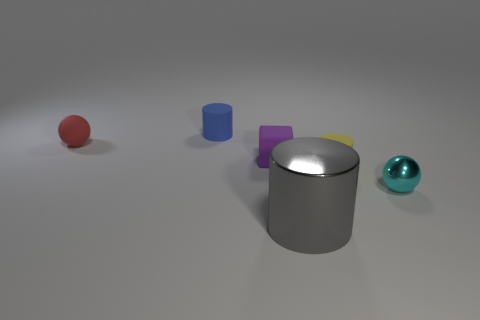Is the material of the small purple thing the same as the ball to the right of the tiny blue thing?
Offer a very short reply. No. There is a metal thing that is on the right side of the metal thing that is left of the tiny sphere right of the tiny purple cube; what color is it?
Your answer should be very brief. Cyan. What material is the cylinder that is the same size as the blue thing?
Offer a terse response. Rubber. What number of spheres are made of the same material as the blue object?
Provide a succinct answer. 1. There is a cylinder that is on the left side of the small rubber cube; is it the same size as the metallic object that is behind the gray shiny object?
Give a very brief answer. Yes. There is a sphere that is to the left of the small cyan metal ball; what color is it?
Your answer should be very brief. Red. There is a cyan shiny thing; is its size the same as the matte cylinder that is on the left side of the big gray shiny cylinder?
Give a very brief answer. Yes. What is the size of the rubber thing on the left side of the tiny rubber cylinder to the left of the cylinder that is right of the large gray cylinder?
Your response must be concise. Small. How many yellow things are to the left of the rubber ball?
Keep it short and to the point. 0. There is a object behind the object on the left side of the tiny blue matte thing; what is its material?
Your response must be concise. Rubber. 